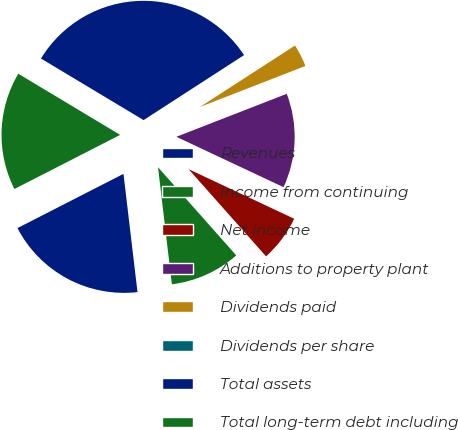Convert chart to OTSL. <chart><loc_0><loc_0><loc_500><loc_500><pie_chart><fcel>Revenues<fcel>Income from continuing<fcel>Net income<fcel>Additions to property plant<fcel>Dividends paid<fcel>Dividends per share<fcel>Total assets<fcel>Total long-term debt including<nl><fcel>19.35%<fcel>9.68%<fcel>6.45%<fcel>12.9%<fcel>3.23%<fcel>0.0%<fcel>32.26%<fcel>16.13%<nl></chart> 